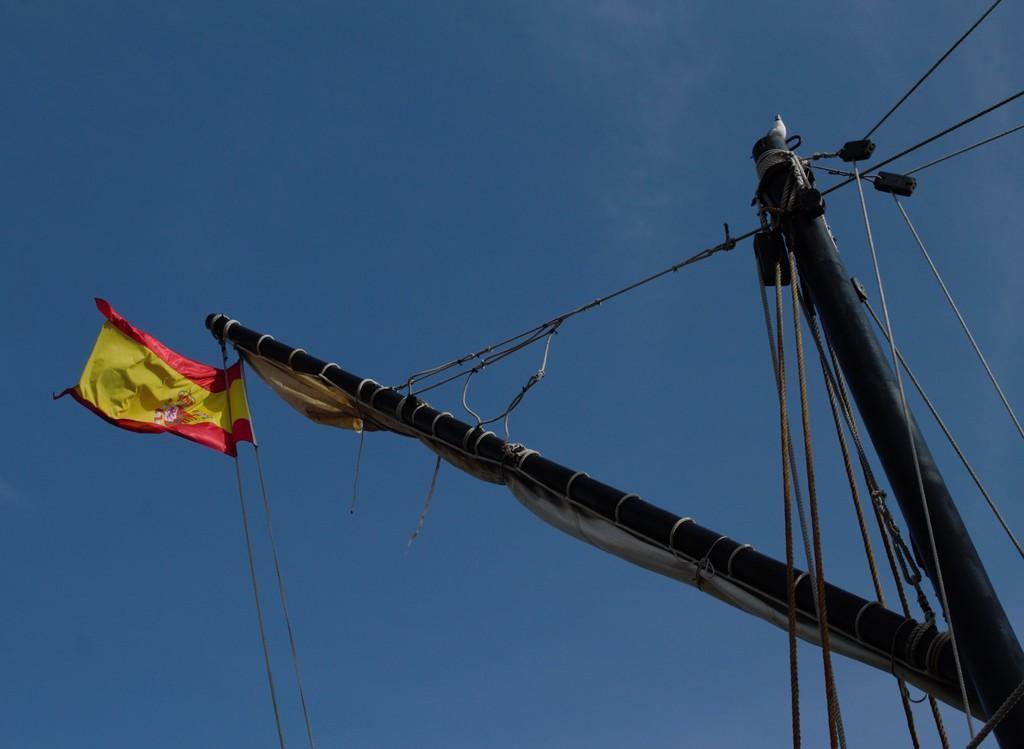How would you summarize this image in a sentence or two? In this image there is a pole and there are some ropes and a flag attached to it. At the top of the pole there is a bird. In the background there is a sky. 